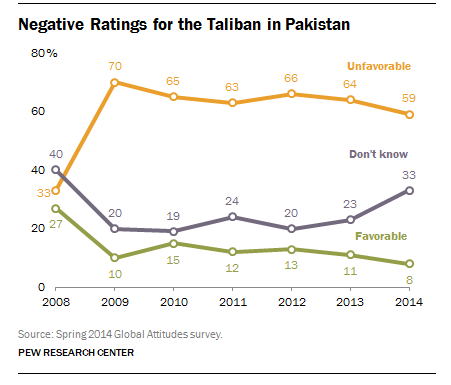Specify some key components in this picture. The color line with the highest value from 2009 to 2014 is orange. The median value of the green line is 12. 